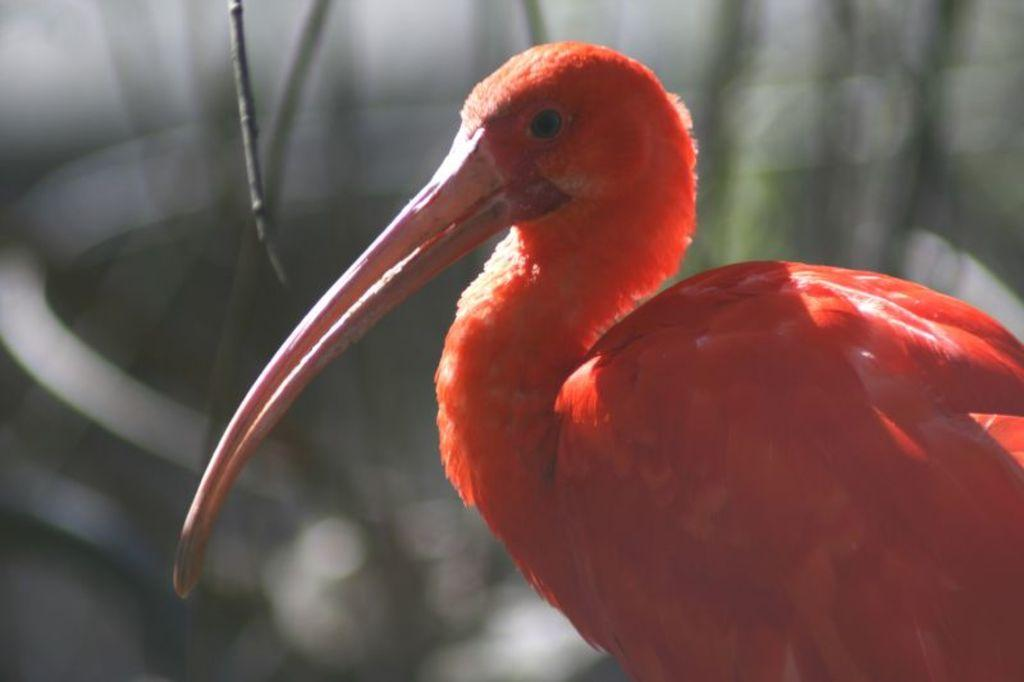What type of animal is in the image? There is a bird in the image. What color is the bird? The bird is orange in color. Can you describe the background of the image? The background of the image is blurred. What type of cracker is the bird holding in its beak in the image? There is no cracker present in the image; the bird is not holding anything in its beak. 